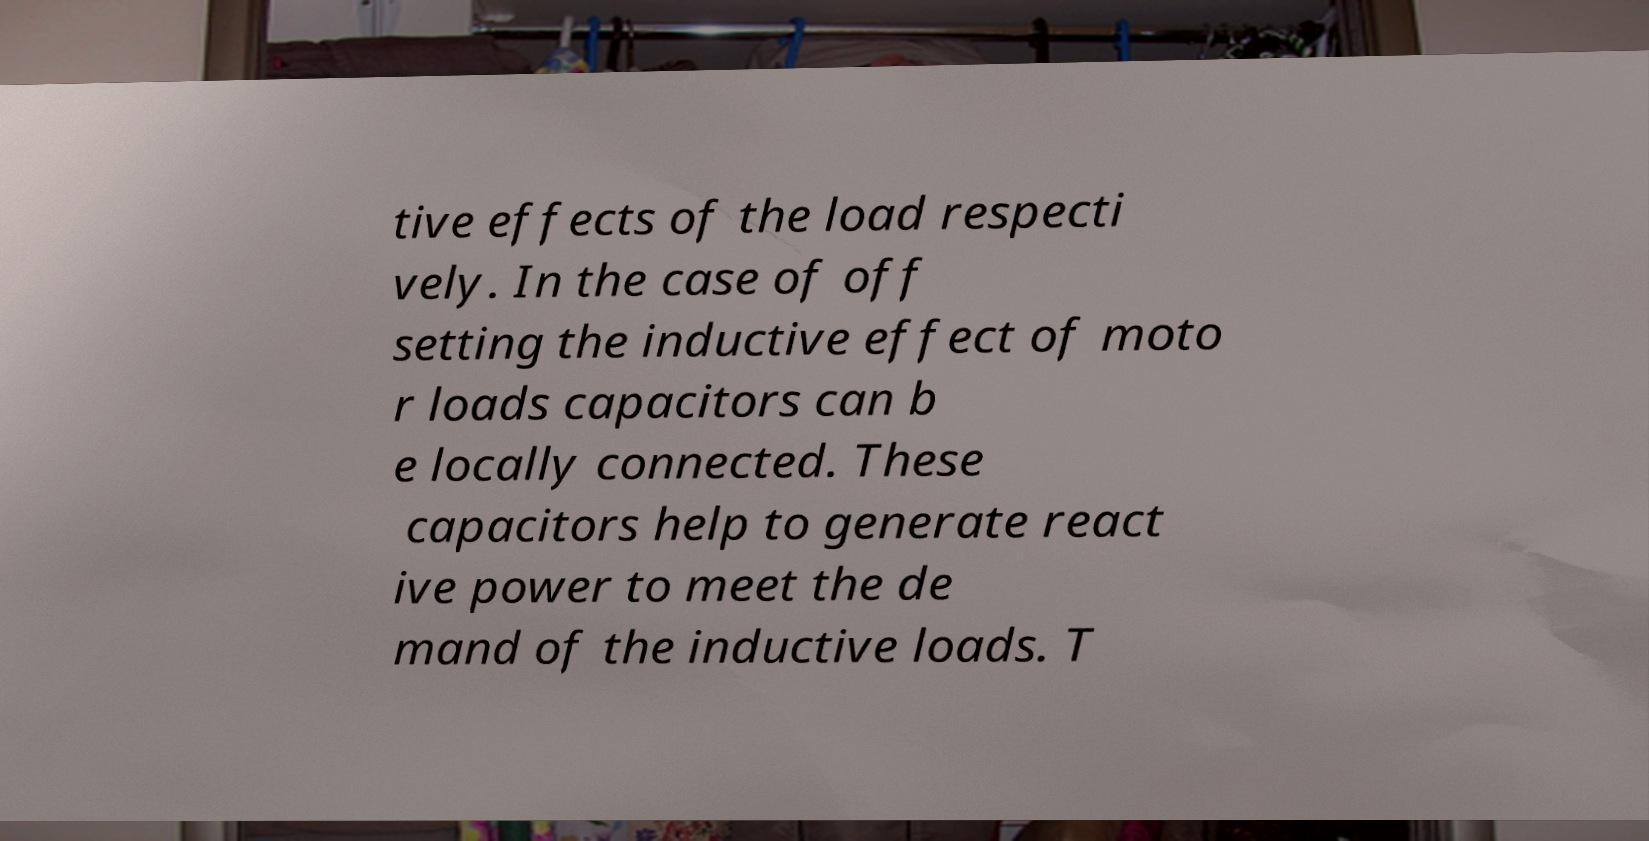Please read and relay the text visible in this image. What does it say? tive effects of the load respecti vely. In the case of off setting the inductive effect of moto r loads capacitors can b e locally connected. These capacitors help to generate react ive power to meet the de mand of the inductive loads. T 